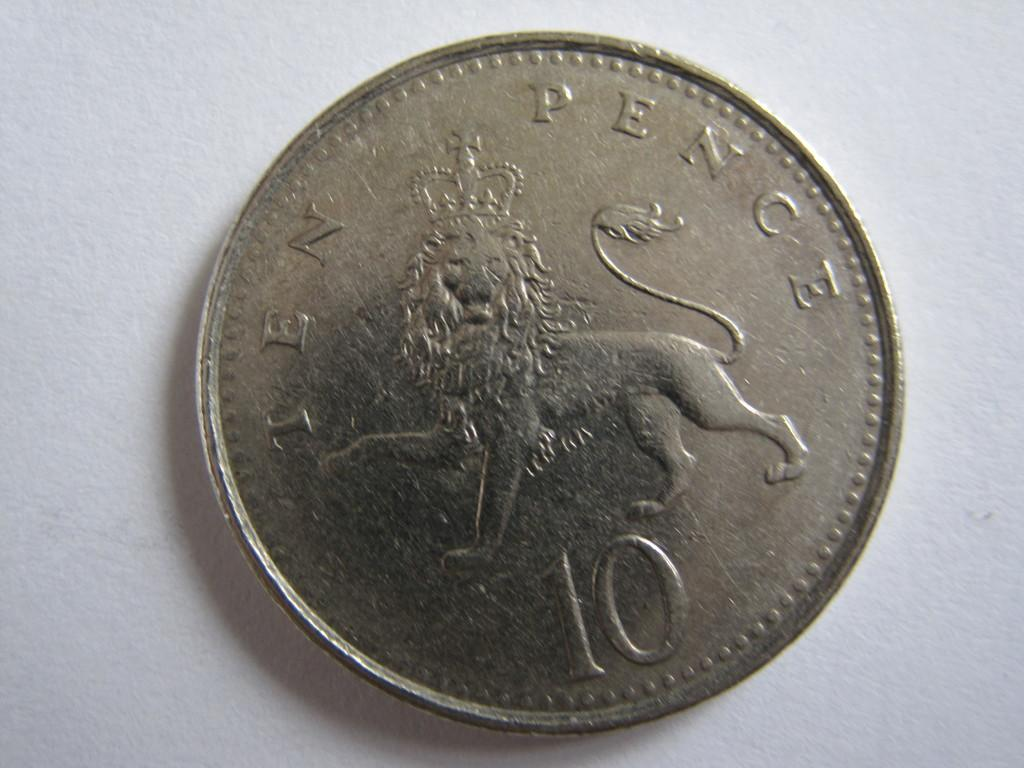Provide a one-sentence caption for the provided image. Silver ten pence with a lion in the middle of it. 